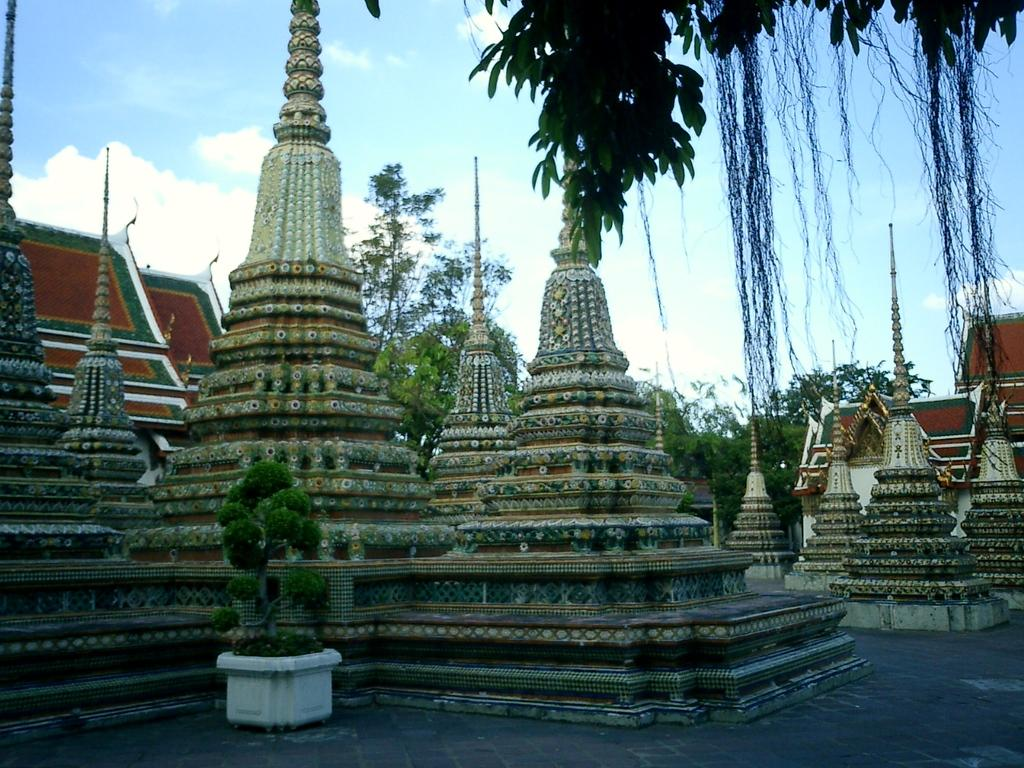What type of structures can be seen in the image? There are architecture pillars in the image. What other elements are present in the image? There are potted plants in the image. What can be seen in the background of the image? There are trees and buildings visible in the background of the image. How much honey can be seen dripping from the architecture pillars in the image? There is no honey present in the image; it features architecture pillars, potted plants, trees, and buildings. What type of attraction is depicted in the image? The image does not depict any specific attraction; it shows architecture pillars, potted plants, trees, and buildings. 